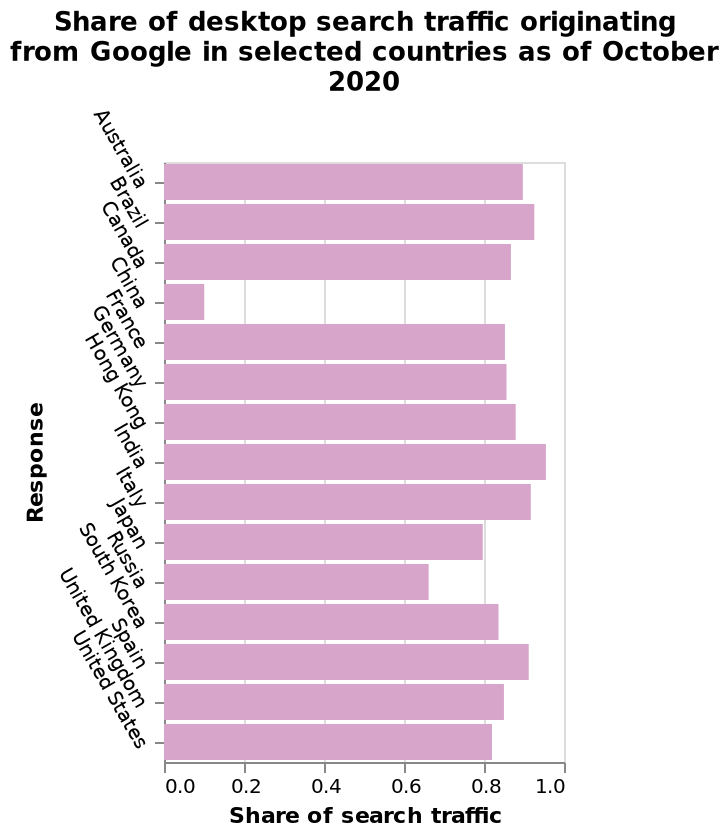<image>
please describe the details of the chart Share of desktop search traffic originating from Google in selected countries as of October 2020 is a bar chart. There is a linear scale of range 0.0 to 1.0 along the x-axis, labeled Share of search traffic. A categorical scale with Australia on one end and United States at the other can be found on the y-axis, labeled Response. What time period does the data cover? The data covers the share of desktop search traffic originating from Google in selected countries as of October 2020. Which countries had more than a 0.8 share of desktop search traffic originating from Google as of October 2020?  Majority of the countries selected had more than a 0.8 share of desktop search traffic originating from Google as of October 2020. 